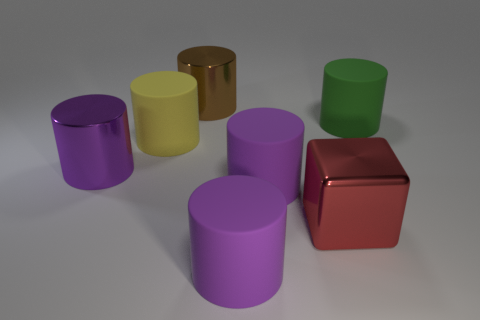Subtract all green blocks. How many purple cylinders are left? 3 Subtract all yellow rubber cylinders. How many cylinders are left? 5 Subtract all yellow cylinders. How many cylinders are left? 5 Subtract all yellow cylinders. Subtract all purple spheres. How many cylinders are left? 5 Add 1 big purple metallic cylinders. How many objects exist? 8 Subtract all cubes. How many objects are left? 6 Add 5 tiny brown metallic things. How many tiny brown metallic things exist? 5 Subtract 0 red cylinders. How many objects are left? 7 Subtract all big purple metal cylinders. Subtract all green cylinders. How many objects are left? 5 Add 4 large metal blocks. How many large metal blocks are left? 5 